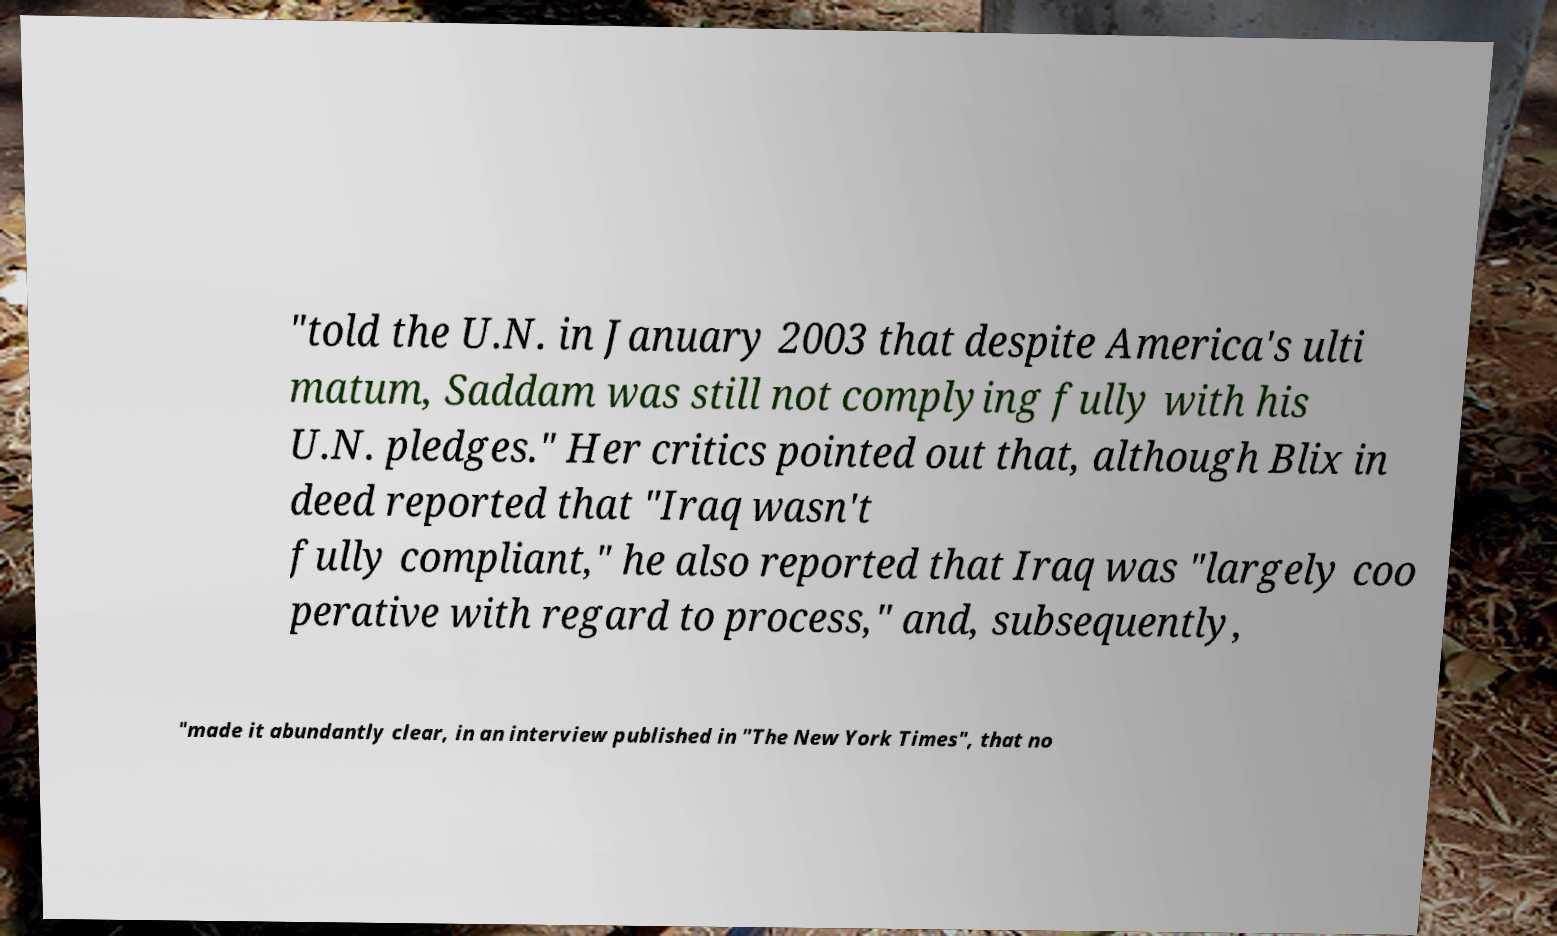What messages or text are displayed in this image? I need them in a readable, typed format. "told the U.N. in January 2003 that despite America's ulti matum, Saddam was still not complying fully with his U.N. pledges." Her critics pointed out that, although Blix in deed reported that "Iraq wasn't fully compliant," he also reported that Iraq was "largely coo perative with regard to process," and, subsequently, "made it abundantly clear, in an interview published in "The New York Times", that no 